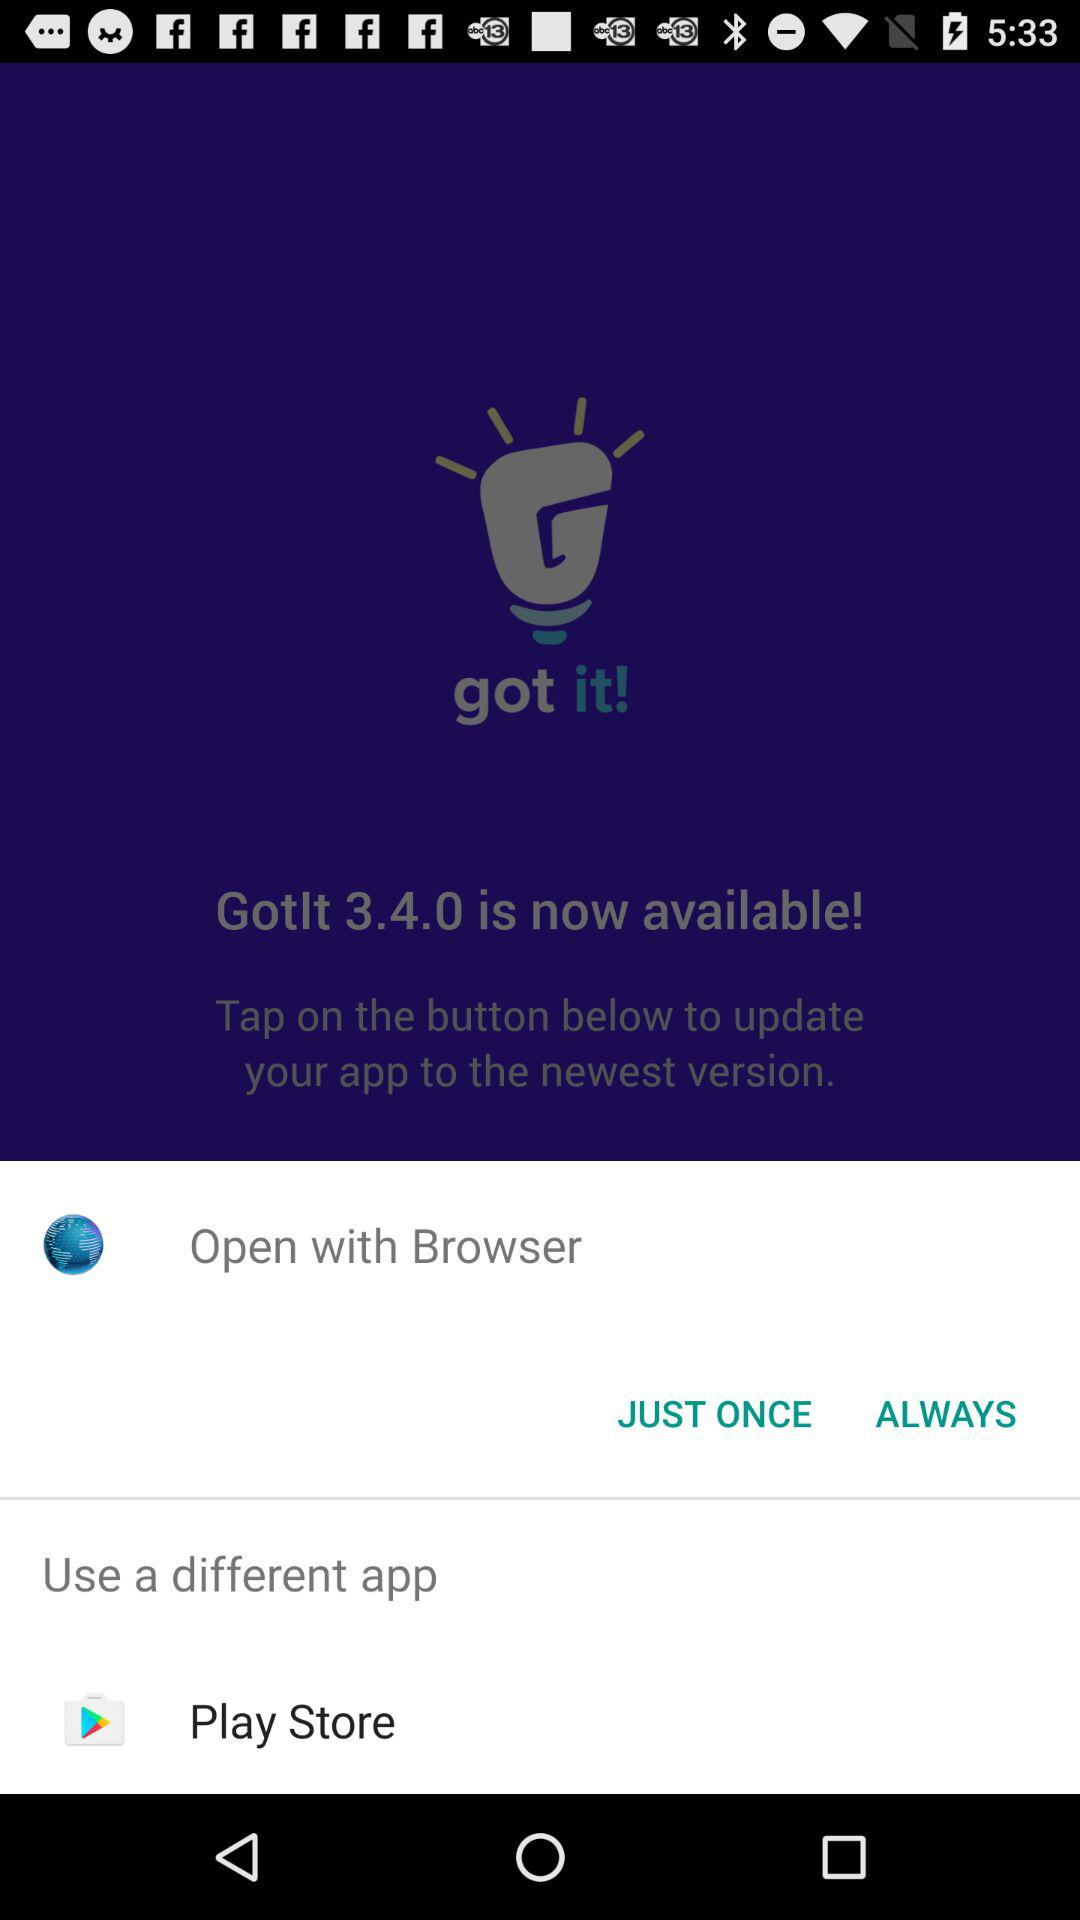What is the version of the application? The version of the application is 3.4.0. 